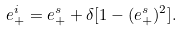<formula> <loc_0><loc_0><loc_500><loc_500>e _ { + } ^ { i } = e _ { + } ^ { s } + \delta [ 1 - ( e _ { + } ^ { s } ) ^ { 2 } ] .</formula> 